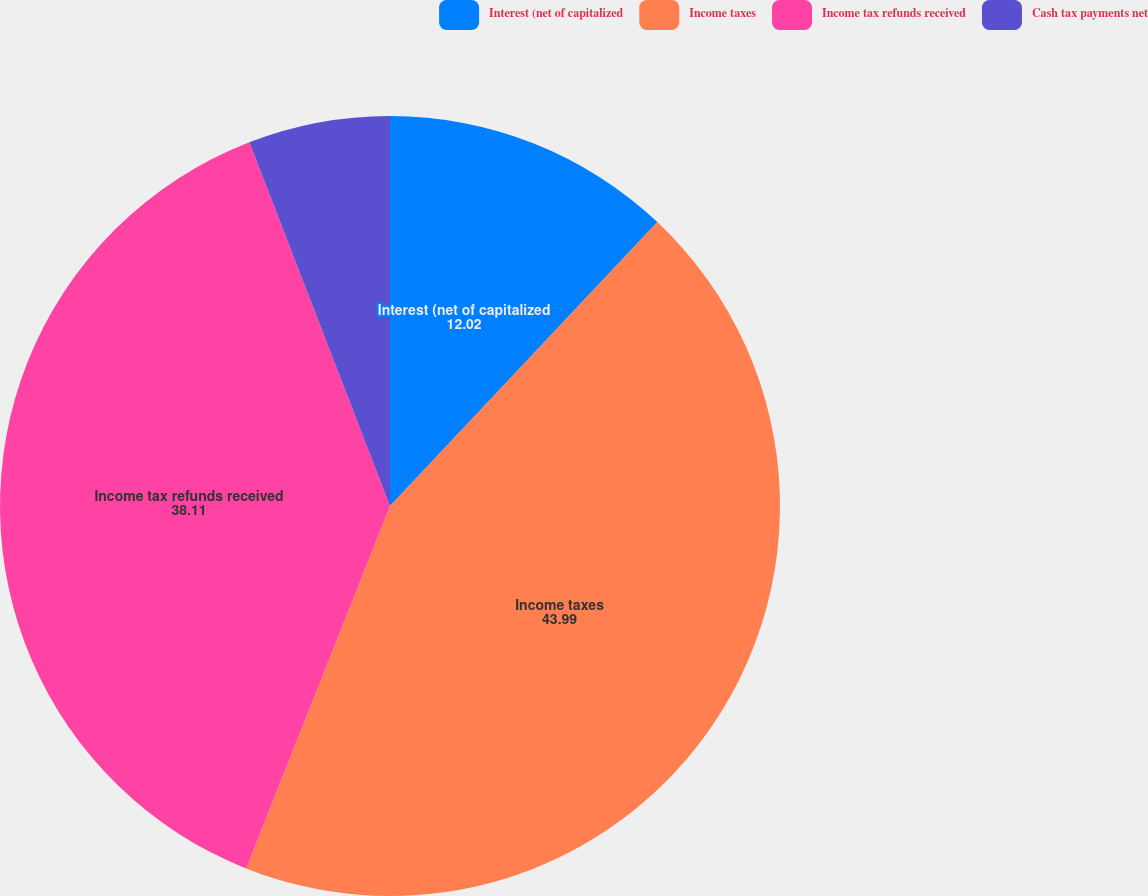<chart> <loc_0><loc_0><loc_500><loc_500><pie_chart><fcel>Interest (net of capitalized<fcel>Income taxes<fcel>Income tax refunds received<fcel>Cash tax payments net<nl><fcel>12.02%<fcel>43.99%<fcel>38.11%<fcel>5.87%<nl></chart> 